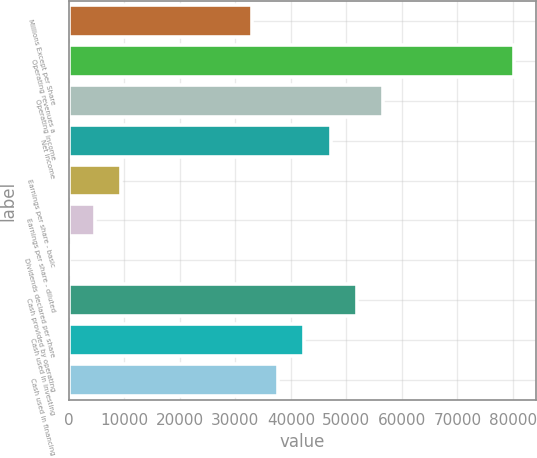<chart> <loc_0><loc_0><loc_500><loc_500><bar_chart><fcel>Millions Except per Share<fcel>Operating revenues a<fcel>Operating income<fcel>Net income<fcel>Earnings per share - basic<fcel>Earnings per share - diluted<fcel>Dividends declared per share<fcel>Cash provided by operating<fcel>Cash used in investing<fcel>Cash used in financing<nl><fcel>33007.8<fcel>80158.3<fcel>56583.1<fcel>47153<fcel>9432.59<fcel>4717.54<fcel>2.49<fcel>51868<fcel>42437.9<fcel>37722.9<nl></chart> 